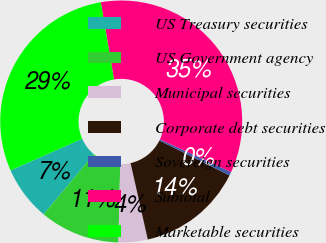Convert chart to OTSL. <chart><loc_0><loc_0><loc_500><loc_500><pie_chart><fcel>US Treasury securities<fcel>US Government agency<fcel>Municipal securities<fcel>Corporate debt securities<fcel>Sovereign securities<fcel>Subtotal<fcel>Marketable securities<nl><fcel>7.3%<fcel>10.71%<fcel>3.89%<fcel>14.12%<fcel>0.49%<fcel>34.57%<fcel>28.93%<nl></chart> 